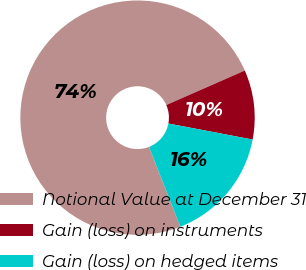Convert chart to OTSL. <chart><loc_0><loc_0><loc_500><loc_500><pie_chart><fcel>Notional Value at December 31<fcel>Gain (loss) on instruments<fcel>Gain (loss) on hedged items<nl><fcel>74.37%<fcel>9.58%<fcel>16.05%<nl></chart> 